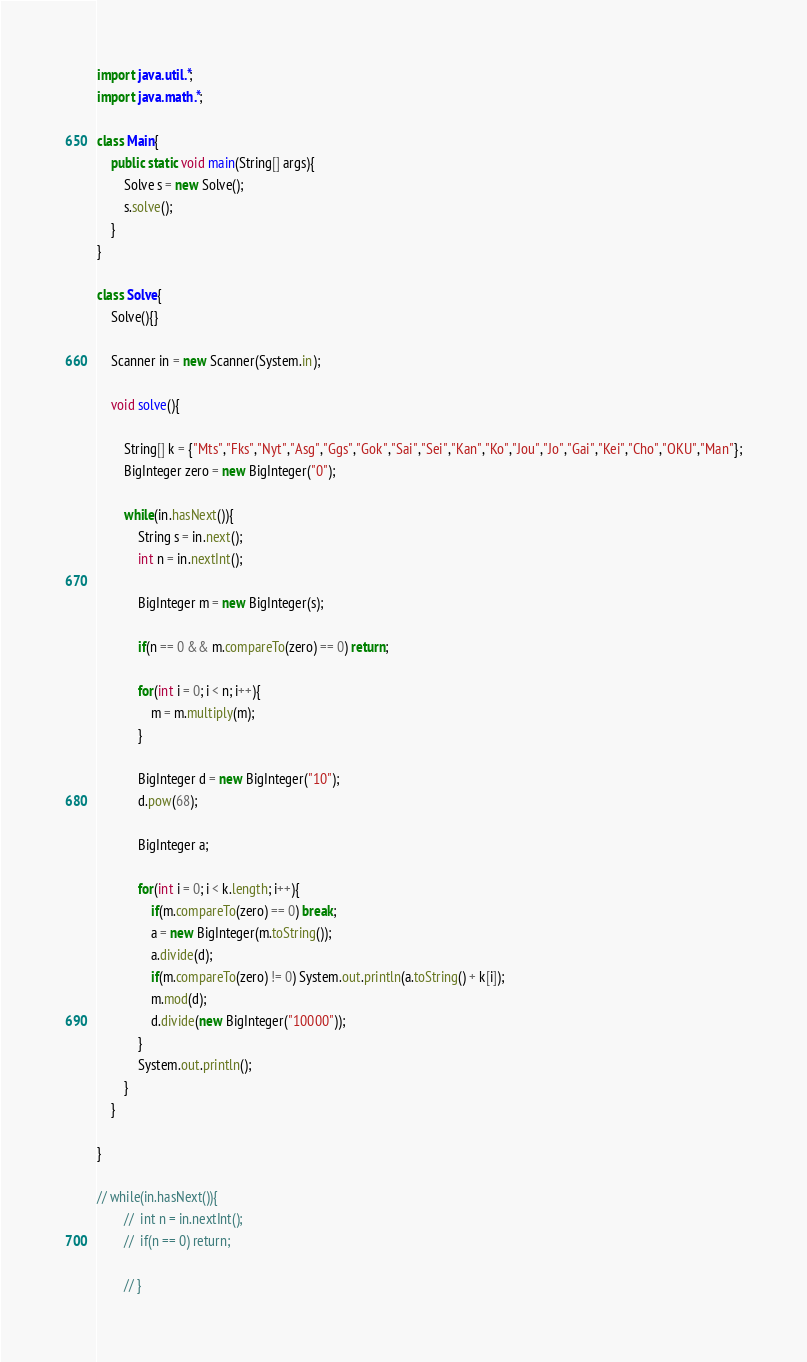<code> <loc_0><loc_0><loc_500><loc_500><_Java_>import java.util.*;
import java.math.*;

class Main{
	public static void main(String[] args){
		Solve s = new Solve();
		s.solve();
	}	
}

class Solve{
	Solve(){}
	
	Scanner in = new Scanner(System.in);

	void solve(){

		String[] k = {"Mts","Fks","Nyt","Asg","Ggs","Gok","Sai","Sei","Kan","Ko","Jou","Jo","Gai","Kei","Cho","OKU","Man"};
		BigInteger zero = new BigInteger("0");

		while(in.hasNext()){
			String s = in.next();
			int n = in.nextInt();

			BigInteger m = new BigInteger(s);

			if(n == 0 && m.compareTo(zero) == 0) return;

			for(int i = 0; i < n; i++){
				m = m.multiply(m);
			}

			BigInteger d = new BigInteger("10");
			d.pow(68);

			BigInteger a;

			for(int i = 0; i < k.length; i++){
				if(m.compareTo(zero) == 0) break;
				a = new BigInteger(m.toString());
				a.divide(d);
				if(m.compareTo(zero) != 0) System.out.println(a.toString() + k[i]);
				m.mod(d);
				d.divide(new BigInteger("10000"));
			}
			System.out.println();
		}
	}
	
}

// while(in.hasNext()){
		// 	int n = in.nextInt();
		// 	if(n == 0) return;
			
		// }</code> 